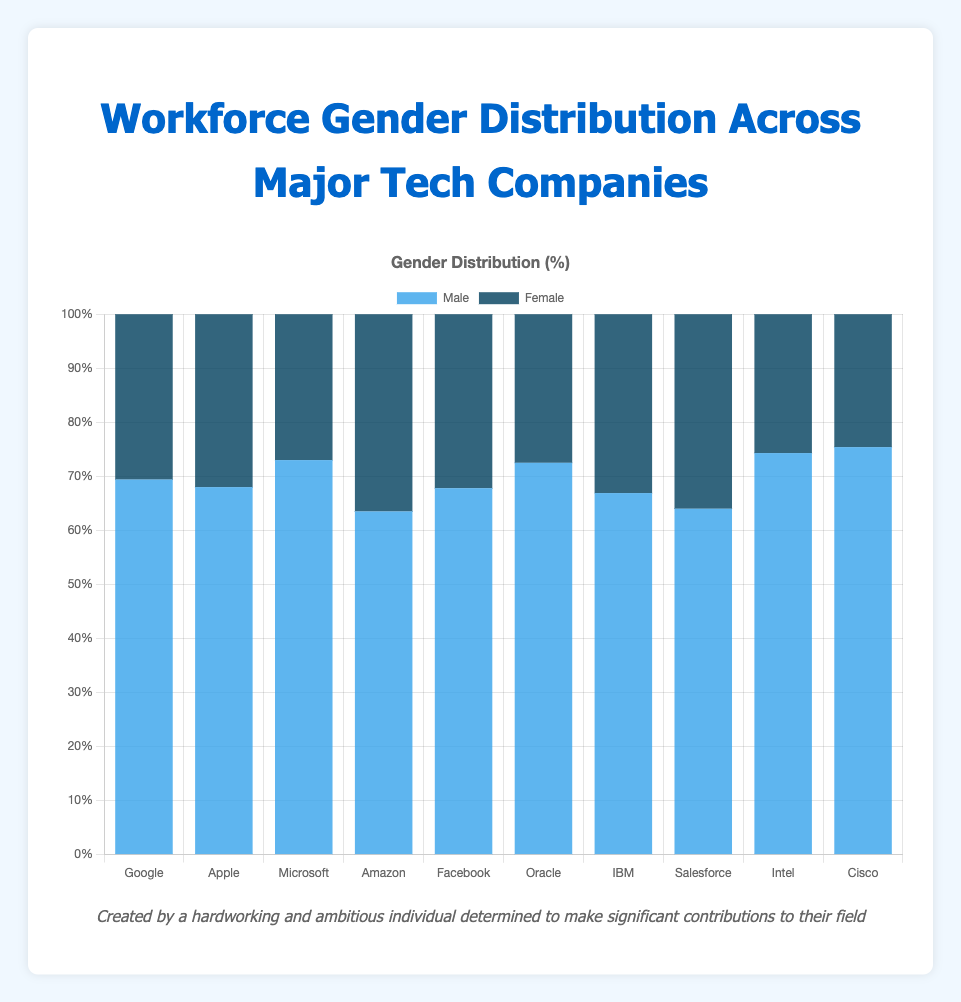Which company has the highest percentage of male employees? To identify the company with the highest percentage of male employees, look at the data on the chart for the blue bars representing the male percentage. Intel has the highest male percentage at 75.4%.
Answer: Intel Which company has the highest percentage of female employees? To identify the company with the highest percentage of female employees, look at the data on the chart for the dark blue bars representing the female percentage. Amazon has the highest female percentage at 36.5%.
Answer: Amazon What is the difference in male percentage between Microsoft and IBM? The difference in the male percentage is found by subtracting the percentage of male employees at IBM from that at Microsoft: 73.0% - 66.9% = 6.1%.
Answer: 6.1% Which company has a higher male-to-female ratio, Oracle or Facebook? To compare the male-to-female ratio for Oracle and Facebook, calculate the ratio for each. Oracle: 72.5% male / 27.5% female ≈ 2.64, Facebook: 67.8% male / 32.2% female ≈ 2.11. Oracle has a higher ratio.
Answer: Oracle What is the average percentage of female employees across all companies? Add the female percentages for all companies and divide by the number of companies to find the average: (30.6 + 32.0 + 27.0 + 36.5 + 32.2 + 27.5 + 33.1 + 36.0 + 25.7 + 24.6) / 10 = 30.52%.
Answer: 30.52% Which companies have more than 70% male employees? Identify companies with more than 70% male employees by looking for blue bars exceeding 70%. These companies are Microsoft (73.0%), Oracle (72.5%), Intel (74.3%), and Cisco (75.4%).
Answer: Microsoft, Oracle, Intel, Cisco Are there any companies where the percentage of female employees is more than double that of Intel's percentage? To verify this, calculate twice the female percentage of Intel: 2 * 25.7% = 51.4%. None of the companies have a female percentage exceeding 51.4%.
Answer: No How does the female representation in Apple compare to Salesforce? Compare the female percentages of both companies: Apple has 32.0% and Salesforce has 36.0%. Salesforce has a higher percentage of female employees.
Answer: Salesforce Which company has a male percentage closest to 65%? Find the company whose male percentage is closest to 65%. IBM has 66.9%, which is closest to 65%.
Answer: IBM How much higher is the male percentage in Google compared to the female percentage in Cisco? The difference is calculated by subtracting the female percentage of Cisco from the male percentage of Google: 69.4% - 24.6% = 44.8%.
Answer: 44.8% 